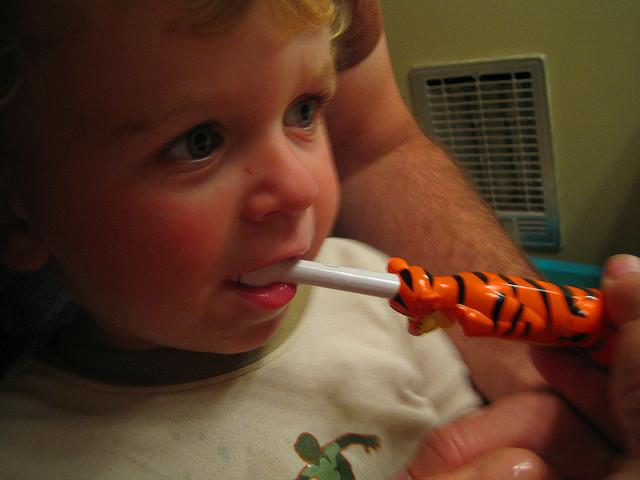What is on the end of tigger's head?

Choices:
A) comb
B) toothbrush
C) sucker
D) hairbrush toothbrush 